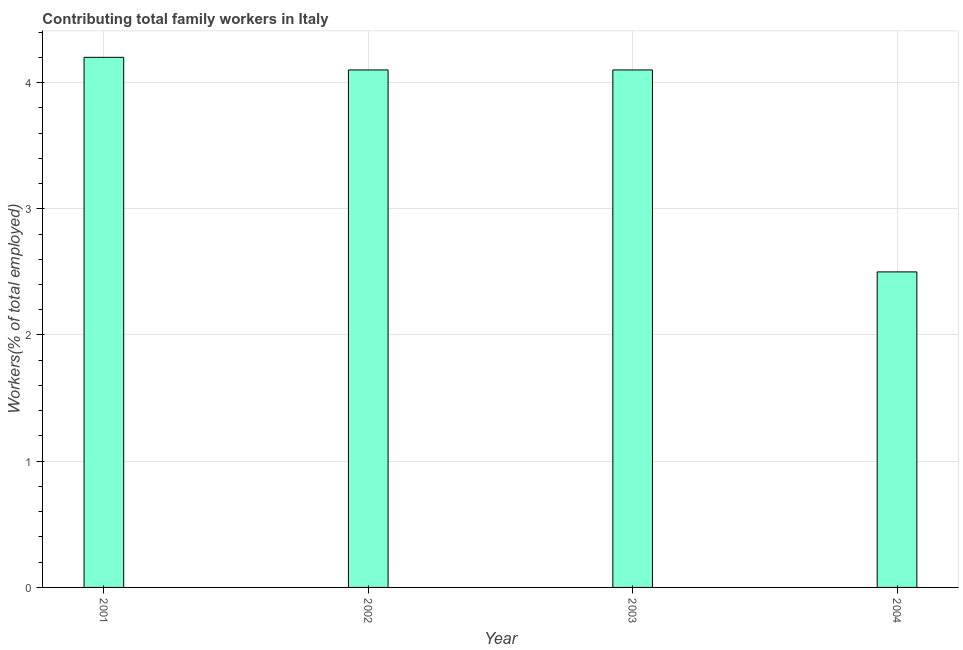What is the title of the graph?
Offer a terse response. Contributing total family workers in Italy. What is the label or title of the X-axis?
Provide a short and direct response. Year. What is the label or title of the Y-axis?
Keep it short and to the point. Workers(% of total employed). What is the contributing family workers in 2001?
Offer a terse response. 4.2. Across all years, what is the maximum contributing family workers?
Offer a terse response. 4.2. In which year was the contributing family workers maximum?
Offer a terse response. 2001. What is the sum of the contributing family workers?
Your response must be concise. 14.9. What is the difference between the contributing family workers in 2002 and 2004?
Provide a short and direct response. 1.6. What is the average contributing family workers per year?
Ensure brevity in your answer.  3.73. What is the median contributing family workers?
Make the answer very short. 4.1. Do a majority of the years between 2003 and 2004 (inclusive) have contributing family workers greater than 0.2 %?
Make the answer very short. Yes. What is the ratio of the contributing family workers in 2001 to that in 2004?
Keep it short and to the point. 1.68. What is the difference between the highest and the second highest contributing family workers?
Keep it short and to the point. 0.1. Is the sum of the contributing family workers in 2002 and 2003 greater than the maximum contributing family workers across all years?
Offer a terse response. Yes. What is the difference between the highest and the lowest contributing family workers?
Your answer should be compact. 1.7. In how many years, is the contributing family workers greater than the average contributing family workers taken over all years?
Keep it short and to the point. 3. Are all the bars in the graph horizontal?
Provide a short and direct response. No. What is the Workers(% of total employed) of 2001?
Your answer should be very brief. 4.2. What is the Workers(% of total employed) in 2002?
Your answer should be very brief. 4.1. What is the Workers(% of total employed) of 2003?
Keep it short and to the point. 4.1. What is the difference between the Workers(% of total employed) in 2001 and 2003?
Make the answer very short. 0.1. What is the difference between the Workers(% of total employed) in 2001 and 2004?
Keep it short and to the point. 1.7. What is the difference between the Workers(% of total employed) in 2002 and 2003?
Provide a short and direct response. 0. What is the difference between the Workers(% of total employed) in 2003 and 2004?
Give a very brief answer. 1.6. What is the ratio of the Workers(% of total employed) in 2001 to that in 2004?
Your answer should be compact. 1.68. What is the ratio of the Workers(% of total employed) in 2002 to that in 2004?
Your answer should be compact. 1.64. What is the ratio of the Workers(% of total employed) in 2003 to that in 2004?
Offer a terse response. 1.64. 